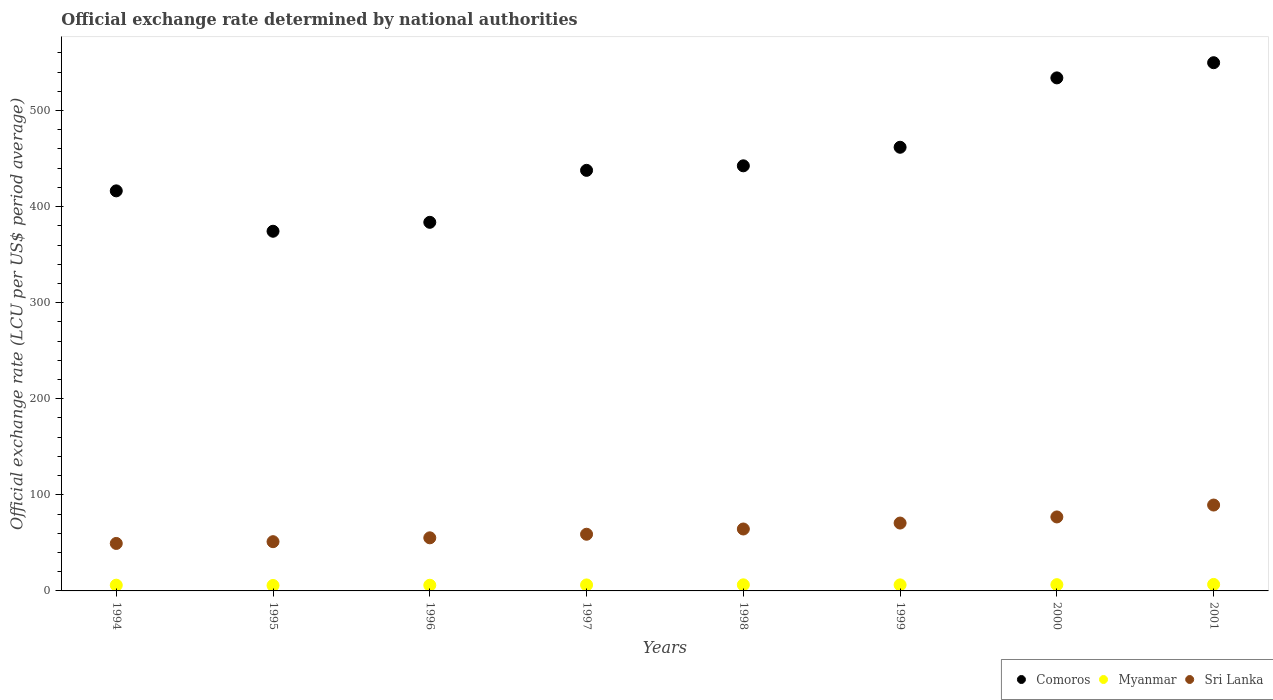How many different coloured dotlines are there?
Your answer should be compact. 3. What is the official exchange rate in Comoros in 1995?
Provide a short and direct response. 374.36. Across all years, what is the maximum official exchange rate in Comoros?
Your answer should be compact. 549.78. Across all years, what is the minimum official exchange rate in Myanmar?
Make the answer very short. 5.67. In which year was the official exchange rate in Myanmar maximum?
Your response must be concise. 2001. What is the total official exchange rate in Comoros in the graph?
Ensure brevity in your answer.  3600.16. What is the difference between the official exchange rate in Myanmar in 1995 and that in 2001?
Provide a succinct answer. -1.08. What is the difference between the official exchange rate in Comoros in 1998 and the official exchange rate in Sri Lanka in 1994?
Provide a succinct answer. 393.04. What is the average official exchange rate in Sri Lanka per year?
Provide a short and direct response. 64.55. In the year 2001, what is the difference between the official exchange rate in Comoros and official exchange rate in Myanmar?
Offer a very short reply. 543.03. What is the ratio of the official exchange rate in Sri Lanka in 1995 to that in 1996?
Offer a terse response. 0.93. Is the official exchange rate in Comoros in 1997 less than that in 2000?
Offer a terse response. Yes. Is the difference between the official exchange rate in Comoros in 1998 and 1999 greater than the difference between the official exchange rate in Myanmar in 1998 and 1999?
Ensure brevity in your answer.  No. What is the difference between the highest and the second highest official exchange rate in Myanmar?
Give a very brief answer. 0.23. What is the difference between the highest and the lowest official exchange rate in Myanmar?
Keep it short and to the point. 1.08. Is the sum of the official exchange rate in Sri Lanka in 1996 and 2001 greater than the maximum official exchange rate in Comoros across all years?
Offer a very short reply. No. Is it the case that in every year, the sum of the official exchange rate in Myanmar and official exchange rate in Sri Lanka  is greater than the official exchange rate in Comoros?
Make the answer very short. No. Does the official exchange rate in Myanmar monotonically increase over the years?
Your answer should be compact. No. Is the official exchange rate in Myanmar strictly less than the official exchange rate in Comoros over the years?
Offer a terse response. Yes. How many years are there in the graph?
Provide a succinct answer. 8. What is the difference between two consecutive major ticks on the Y-axis?
Make the answer very short. 100. Where does the legend appear in the graph?
Offer a very short reply. Bottom right. How many legend labels are there?
Keep it short and to the point. 3. What is the title of the graph?
Offer a terse response. Official exchange rate determined by national authorities. What is the label or title of the X-axis?
Your response must be concise. Years. What is the label or title of the Y-axis?
Provide a short and direct response. Official exchange rate (LCU per US$ period average). What is the Official exchange rate (LCU per US$ period average) in Comoros in 1994?
Provide a succinct answer. 416.4. What is the Official exchange rate (LCU per US$ period average) of Myanmar in 1994?
Your response must be concise. 5.97. What is the Official exchange rate (LCU per US$ period average) of Sri Lanka in 1994?
Your answer should be very brief. 49.42. What is the Official exchange rate (LCU per US$ period average) of Comoros in 1995?
Offer a very short reply. 374.36. What is the Official exchange rate (LCU per US$ period average) of Myanmar in 1995?
Provide a succinct answer. 5.67. What is the Official exchange rate (LCU per US$ period average) in Sri Lanka in 1995?
Provide a short and direct response. 51.25. What is the Official exchange rate (LCU per US$ period average) of Comoros in 1996?
Make the answer very short. 383.66. What is the Official exchange rate (LCU per US$ period average) in Myanmar in 1996?
Ensure brevity in your answer.  5.92. What is the Official exchange rate (LCU per US$ period average) of Sri Lanka in 1996?
Keep it short and to the point. 55.27. What is the Official exchange rate (LCU per US$ period average) in Comoros in 1997?
Ensure brevity in your answer.  437.75. What is the Official exchange rate (LCU per US$ period average) in Myanmar in 1997?
Make the answer very short. 6.24. What is the Official exchange rate (LCU per US$ period average) in Sri Lanka in 1997?
Keep it short and to the point. 58.99. What is the Official exchange rate (LCU per US$ period average) of Comoros in 1998?
Offer a very short reply. 442.46. What is the Official exchange rate (LCU per US$ period average) in Myanmar in 1998?
Ensure brevity in your answer.  6.34. What is the Official exchange rate (LCU per US$ period average) in Sri Lanka in 1998?
Your answer should be very brief. 64.45. What is the Official exchange rate (LCU per US$ period average) in Comoros in 1999?
Offer a very short reply. 461.77. What is the Official exchange rate (LCU per US$ period average) of Myanmar in 1999?
Offer a terse response. 6.29. What is the Official exchange rate (LCU per US$ period average) of Sri Lanka in 1999?
Your answer should be compact. 70.64. What is the Official exchange rate (LCU per US$ period average) of Comoros in 2000?
Make the answer very short. 533.98. What is the Official exchange rate (LCU per US$ period average) in Myanmar in 2000?
Your answer should be compact. 6.52. What is the Official exchange rate (LCU per US$ period average) of Sri Lanka in 2000?
Provide a short and direct response. 77.01. What is the Official exchange rate (LCU per US$ period average) in Comoros in 2001?
Give a very brief answer. 549.78. What is the Official exchange rate (LCU per US$ period average) in Myanmar in 2001?
Provide a short and direct response. 6.75. What is the Official exchange rate (LCU per US$ period average) of Sri Lanka in 2001?
Offer a terse response. 89.38. Across all years, what is the maximum Official exchange rate (LCU per US$ period average) of Comoros?
Ensure brevity in your answer.  549.78. Across all years, what is the maximum Official exchange rate (LCU per US$ period average) in Myanmar?
Give a very brief answer. 6.75. Across all years, what is the maximum Official exchange rate (LCU per US$ period average) in Sri Lanka?
Ensure brevity in your answer.  89.38. Across all years, what is the minimum Official exchange rate (LCU per US$ period average) of Comoros?
Give a very brief answer. 374.36. Across all years, what is the minimum Official exchange rate (LCU per US$ period average) in Myanmar?
Your answer should be very brief. 5.67. Across all years, what is the minimum Official exchange rate (LCU per US$ period average) in Sri Lanka?
Offer a terse response. 49.42. What is the total Official exchange rate (LCU per US$ period average) in Comoros in the graph?
Keep it short and to the point. 3600.16. What is the total Official exchange rate (LCU per US$ period average) in Myanmar in the graph?
Offer a very short reply. 49.7. What is the total Official exchange rate (LCU per US$ period average) of Sri Lanka in the graph?
Provide a succinct answer. 516.41. What is the difference between the Official exchange rate (LCU per US$ period average) of Comoros in 1994 and that in 1995?
Ensure brevity in your answer.  42.04. What is the difference between the Official exchange rate (LCU per US$ period average) in Myanmar in 1994 and that in 1995?
Ensure brevity in your answer.  0.31. What is the difference between the Official exchange rate (LCU per US$ period average) of Sri Lanka in 1994 and that in 1995?
Provide a short and direct response. -1.84. What is the difference between the Official exchange rate (LCU per US$ period average) in Comoros in 1994 and that in 1996?
Offer a terse response. 32.74. What is the difference between the Official exchange rate (LCU per US$ period average) of Myanmar in 1994 and that in 1996?
Provide a succinct answer. 0.06. What is the difference between the Official exchange rate (LCU per US$ period average) in Sri Lanka in 1994 and that in 1996?
Provide a short and direct response. -5.86. What is the difference between the Official exchange rate (LCU per US$ period average) in Comoros in 1994 and that in 1997?
Keep it short and to the point. -21.35. What is the difference between the Official exchange rate (LCU per US$ period average) of Myanmar in 1994 and that in 1997?
Provide a succinct answer. -0.27. What is the difference between the Official exchange rate (LCU per US$ period average) of Sri Lanka in 1994 and that in 1997?
Make the answer very short. -9.58. What is the difference between the Official exchange rate (LCU per US$ period average) of Comoros in 1994 and that in 1998?
Your answer should be compact. -26.06. What is the difference between the Official exchange rate (LCU per US$ period average) in Myanmar in 1994 and that in 1998?
Make the answer very short. -0.37. What is the difference between the Official exchange rate (LCU per US$ period average) of Sri Lanka in 1994 and that in 1998?
Provide a succinct answer. -15.04. What is the difference between the Official exchange rate (LCU per US$ period average) in Comoros in 1994 and that in 1999?
Your response must be concise. -45.38. What is the difference between the Official exchange rate (LCU per US$ period average) of Myanmar in 1994 and that in 1999?
Your response must be concise. -0.31. What is the difference between the Official exchange rate (LCU per US$ period average) of Sri Lanka in 1994 and that in 1999?
Keep it short and to the point. -21.22. What is the difference between the Official exchange rate (LCU per US$ period average) in Comoros in 1994 and that in 2000?
Give a very brief answer. -117.58. What is the difference between the Official exchange rate (LCU per US$ period average) in Myanmar in 1994 and that in 2000?
Provide a short and direct response. -0.54. What is the difference between the Official exchange rate (LCU per US$ period average) in Sri Lanka in 1994 and that in 2000?
Keep it short and to the point. -27.59. What is the difference between the Official exchange rate (LCU per US$ period average) in Comoros in 1994 and that in 2001?
Ensure brevity in your answer.  -133.38. What is the difference between the Official exchange rate (LCU per US$ period average) in Myanmar in 1994 and that in 2001?
Provide a succinct answer. -0.77. What is the difference between the Official exchange rate (LCU per US$ period average) of Sri Lanka in 1994 and that in 2001?
Make the answer very short. -39.97. What is the difference between the Official exchange rate (LCU per US$ period average) of Comoros in 1995 and that in 1996?
Offer a terse response. -9.3. What is the difference between the Official exchange rate (LCU per US$ period average) in Myanmar in 1995 and that in 1996?
Your response must be concise. -0.25. What is the difference between the Official exchange rate (LCU per US$ period average) of Sri Lanka in 1995 and that in 1996?
Your answer should be very brief. -4.02. What is the difference between the Official exchange rate (LCU per US$ period average) in Comoros in 1995 and that in 1997?
Your response must be concise. -63.39. What is the difference between the Official exchange rate (LCU per US$ period average) of Myanmar in 1995 and that in 1997?
Offer a terse response. -0.57. What is the difference between the Official exchange rate (LCU per US$ period average) in Sri Lanka in 1995 and that in 1997?
Provide a succinct answer. -7.74. What is the difference between the Official exchange rate (LCU per US$ period average) of Comoros in 1995 and that in 1998?
Give a very brief answer. -68.1. What is the difference between the Official exchange rate (LCU per US$ period average) in Myanmar in 1995 and that in 1998?
Your response must be concise. -0.68. What is the difference between the Official exchange rate (LCU per US$ period average) in Sri Lanka in 1995 and that in 1998?
Provide a short and direct response. -13.2. What is the difference between the Official exchange rate (LCU per US$ period average) in Comoros in 1995 and that in 1999?
Give a very brief answer. -87.42. What is the difference between the Official exchange rate (LCU per US$ period average) in Myanmar in 1995 and that in 1999?
Make the answer very short. -0.62. What is the difference between the Official exchange rate (LCU per US$ period average) of Sri Lanka in 1995 and that in 1999?
Make the answer very short. -19.38. What is the difference between the Official exchange rate (LCU per US$ period average) in Comoros in 1995 and that in 2000?
Your answer should be very brief. -159.63. What is the difference between the Official exchange rate (LCU per US$ period average) of Myanmar in 1995 and that in 2000?
Keep it short and to the point. -0.85. What is the difference between the Official exchange rate (LCU per US$ period average) in Sri Lanka in 1995 and that in 2000?
Give a very brief answer. -25.75. What is the difference between the Official exchange rate (LCU per US$ period average) in Comoros in 1995 and that in 2001?
Keep it short and to the point. -175.42. What is the difference between the Official exchange rate (LCU per US$ period average) in Myanmar in 1995 and that in 2001?
Keep it short and to the point. -1.08. What is the difference between the Official exchange rate (LCU per US$ period average) in Sri Lanka in 1995 and that in 2001?
Offer a terse response. -38.13. What is the difference between the Official exchange rate (LCU per US$ period average) in Comoros in 1996 and that in 1997?
Keep it short and to the point. -54.09. What is the difference between the Official exchange rate (LCU per US$ period average) of Myanmar in 1996 and that in 1997?
Your answer should be very brief. -0.32. What is the difference between the Official exchange rate (LCU per US$ period average) in Sri Lanka in 1996 and that in 1997?
Provide a succinct answer. -3.72. What is the difference between the Official exchange rate (LCU per US$ period average) in Comoros in 1996 and that in 1998?
Offer a terse response. -58.8. What is the difference between the Official exchange rate (LCU per US$ period average) of Myanmar in 1996 and that in 1998?
Provide a short and direct response. -0.43. What is the difference between the Official exchange rate (LCU per US$ period average) in Sri Lanka in 1996 and that in 1998?
Make the answer very short. -9.18. What is the difference between the Official exchange rate (LCU per US$ period average) in Comoros in 1996 and that in 1999?
Provide a short and direct response. -78.11. What is the difference between the Official exchange rate (LCU per US$ period average) in Myanmar in 1996 and that in 1999?
Make the answer very short. -0.37. What is the difference between the Official exchange rate (LCU per US$ period average) of Sri Lanka in 1996 and that in 1999?
Provide a succinct answer. -15.36. What is the difference between the Official exchange rate (LCU per US$ period average) of Comoros in 1996 and that in 2000?
Give a very brief answer. -150.32. What is the difference between the Official exchange rate (LCU per US$ period average) in Myanmar in 1996 and that in 2000?
Your answer should be very brief. -0.6. What is the difference between the Official exchange rate (LCU per US$ period average) in Sri Lanka in 1996 and that in 2000?
Your response must be concise. -21.73. What is the difference between the Official exchange rate (LCU per US$ period average) in Comoros in 1996 and that in 2001?
Provide a short and direct response. -166.12. What is the difference between the Official exchange rate (LCU per US$ period average) in Myanmar in 1996 and that in 2001?
Your answer should be compact. -0.83. What is the difference between the Official exchange rate (LCU per US$ period average) in Sri Lanka in 1996 and that in 2001?
Make the answer very short. -34.11. What is the difference between the Official exchange rate (LCU per US$ period average) of Comoros in 1997 and that in 1998?
Provide a succinct answer. -4.71. What is the difference between the Official exchange rate (LCU per US$ period average) of Myanmar in 1997 and that in 1998?
Provide a short and direct response. -0.1. What is the difference between the Official exchange rate (LCU per US$ period average) in Sri Lanka in 1997 and that in 1998?
Your answer should be compact. -5.46. What is the difference between the Official exchange rate (LCU per US$ period average) in Comoros in 1997 and that in 1999?
Offer a very short reply. -24.03. What is the difference between the Official exchange rate (LCU per US$ period average) of Myanmar in 1997 and that in 1999?
Offer a very short reply. -0.04. What is the difference between the Official exchange rate (LCU per US$ period average) of Sri Lanka in 1997 and that in 1999?
Offer a very short reply. -11.64. What is the difference between the Official exchange rate (LCU per US$ period average) of Comoros in 1997 and that in 2000?
Ensure brevity in your answer.  -96.24. What is the difference between the Official exchange rate (LCU per US$ period average) of Myanmar in 1997 and that in 2000?
Give a very brief answer. -0.27. What is the difference between the Official exchange rate (LCU per US$ period average) in Sri Lanka in 1997 and that in 2000?
Your response must be concise. -18.01. What is the difference between the Official exchange rate (LCU per US$ period average) of Comoros in 1997 and that in 2001?
Your answer should be compact. -112.03. What is the difference between the Official exchange rate (LCU per US$ period average) in Myanmar in 1997 and that in 2001?
Give a very brief answer. -0.51. What is the difference between the Official exchange rate (LCU per US$ period average) of Sri Lanka in 1997 and that in 2001?
Keep it short and to the point. -30.39. What is the difference between the Official exchange rate (LCU per US$ period average) of Comoros in 1998 and that in 1999?
Offer a terse response. -19.32. What is the difference between the Official exchange rate (LCU per US$ period average) of Myanmar in 1998 and that in 1999?
Provide a succinct answer. 0.06. What is the difference between the Official exchange rate (LCU per US$ period average) of Sri Lanka in 1998 and that in 1999?
Your answer should be compact. -6.19. What is the difference between the Official exchange rate (LCU per US$ period average) in Comoros in 1998 and that in 2000?
Your response must be concise. -91.52. What is the difference between the Official exchange rate (LCU per US$ period average) in Myanmar in 1998 and that in 2000?
Your answer should be very brief. -0.17. What is the difference between the Official exchange rate (LCU per US$ period average) in Sri Lanka in 1998 and that in 2000?
Offer a terse response. -12.55. What is the difference between the Official exchange rate (LCU per US$ period average) in Comoros in 1998 and that in 2001?
Your answer should be compact. -107.32. What is the difference between the Official exchange rate (LCU per US$ period average) of Myanmar in 1998 and that in 2001?
Your response must be concise. -0.41. What is the difference between the Official exchange rate (LCU per US$ period average) in Sri Lanka in 1998 and that in 2001?
Make the answer very short. -24.93. What is the difference between the Official exchange rate (LCU per US$ period average) in Comoros in 1999 and that in 2000?
Provide a short and direct response. -72.21. What is the difference between the Official exchange rate (LCU per US$ period average) in Myanmar in 1999 and that in 2000?
Offer a very short reply. -0.23. What is the difference between the Official exchange rate (LCU per US$ period average) of Sri Lanka in 1999 and that in 2000?
Your answer should be very brief. -6.37. What is the difference between the Official exchange rate (LCU per US$ period average) of Comoros in 1999 and that in 2001?
Provide a succinct answer. -88. What is the difference between the Official exchange rate (LCU per US$ period average) in Myanmar in 1999 and that in 2001?
Your answer should be very brief. -0.46. What is the difference between the Official exchange rate (LCU per US$ period average) of Sri Lanka in 1999 and that in 2001?
Give a very brief answer. -18.75. What is the difference between the Official exchange rate (LCU per US$ period average) of Comoros in 2000 and that in 2001?
Give a very brief answer. -15.8. What is the difference between the Official exchange rate (LCU per US$ period average) in Myanmar in 2000 and that in 2001?
Provide a short and direct response. -0.23. What is the difference between the Official exchange rate (LCU per US$ period average) of Sri Lanka in 2000 and that in 2001?
Provide a short and direct response. -12.38. What is the difference between the Official exchange rate (LCU per US$ period average) in Comoros in 1994 and the Official exchange rate (LCU per US$ period average) in Myanmar in 1995?
Keep it short and to the point. 410.73. What is the difference between the Official exchange rate (LCU per US$ period average) in Comoros in 1994 and the Official exchange rate (LCU per US$ period average) in Sri Lanka in 1995?
Provide a succinct answer. 365.15. What is the difference between the Official exchange rate (LCU per US$ period average) of Myanmar in 1994 and the Official exchange rate (LCU per US$ period average) of Sri Lanka in 1995?
Keep it short and to the point. -45.28. What is the difference between the Official exchange rate (LCU per US$ period average) in Comoros in 1994 and the Official exchange rate (LCU per US$ period average) in Myanmar in 1996?
Ensure brevity in your answer.  410.48. What is the difference between the Official exchange rate (LCU per US$ period average) in Comoros in 1994 and the Official exchange rate (LCU per US$ period average) in Sri Lanka in 1996?
Your answer should be compact. 361.13. What is the difference between the Official exchange rate (LCU per US$ period average) in Myanmar in 1994 and the Official exchange rate (LCU per US$ period average) in Sri Lanka in 1996?
Your answer should be very brief. -49.3. What is the difference between the Official exchange rate (LCU per US$ period average) of Comoros in 1994 and the Official exchange rate (LCU per US$ period average) of Myanmar in 1997?
Your response must be concise. 410.16. What is the difference between the Official exchange rate (LCU per US$ period average) of Comoros in 1994 and the Official exchange rate (LCU per US$ period average) of Sri Lanka in 1997?
Make the answer very short. 357.4. What is the difference between the Official exchange rate (LCU per US$ period average) of Myanmar in 1994 and the Official exchange rate (LCU per US$ period average) of Sri Lanka in 1997?
Keep it short and to the point. -53.02. What is the difference between the Official exchange rate (LCU per US$ period average) in Comoros in 1994 and the Official exchange rate (LCU per US$ period average) in Myanmar in 1998?
Your response must be concise. 410.06. What is the difference between the Official exchange rate (LCU per US$ period average) of Comoros in 1994 and the Official exchange rate (LCU per US$ period average) of Sri Lanka in 1998?
Give a very brief answer. 351.95. What is the difference between the Official exchange rate (LCU per US$ period average) in Myanmar in 1994 and the Official exchange rate (LCU per US$ period average) in Sri Lanka in 1998?
Your answer should be compact. -58.48. What is the difference between the Official exchange rate (LCU per US$ period average) in Comoros in 1994 and the Official exchange rate (LCU per US$ period average) in Myanmar in 1999?
Your answer should be compact. 410.11. What is the difference between the Official exchange rate (LCU per US$ period average) in Comoros in 1994 and the Official exchange rate (LCU per US$ period average) in Sri Lanka in 1999?
Provide a succinct answer. 345.76. What is the difference between the Official exchange rate (LCU per US$ period average) of Myanmar in 1994 and the Official exchange rate (LCU per US$ period average) of Sri Lanka in 1999?
Your answer should be very brief. -64.66. What is the difference between the Official exchange rate (LCU per US$ period average) of Comoros in 1994 and the Official exchange rate (LCU per US$ period average) of Myanmar in 2000?
Give a very brief answer. 409.88. What is the difference between the Official exchange rate (LCU per US$ period average) in Comoros in 1994 and the Official exchange rate (LCU per US$ period average) in Sri Lanka in 2000?
Offer a terse response. 339.39. What is the difference between the Official exchange rate (LCU per US$ period average) in Myanmar in 1994 and the Official exchange rate (LCU per US$ period average) in Sri Lanka in 2000?
Offer a terse response. -71.03. What is the difference between the Official exchange rate (LCU per US$ period average) of Comoros in 1994 and the Official exchange rate (LCU per US$ period average) of Myanmar in 2001?
Offer a very short reply. 409.65. What is the difference between the Official exchange rate (LCU per US$ period average) of Comoros in 1994 and the Official exchange rate (LCU per US$ period average) of Sri Lanka in 2001?
Keep it short and to the point. 327.02. What is the difference between the Official exchange rate (LCU per US$ period average) in Myanmar in 1994 and the Official exchange rate (LCU per US$ period average) in Sri Lanka in 2001?
Your answer should be compact. -83.41. What is the difference between the Official exchange rate (LCU per US$ period average) in Comoros in 1995 and the Official exchange rate (LCU per US$ period average) in Myanmar in 1996?
Provide a short and direct response. 368.44. What is the difference between the Official exchange rate (LCU per US$ period average) of Comoros in 1995 and the Official exchange rate (LCU per US$ period average) of Sri Lanka in 1996?
Your response must be concise. 319.09. What is the difference between the Official exchange rate (LCU per US$ period average) in Myanmar in 1995 and the Official exchange rate (LCU per US$ period average) in Sri Lanka in 1996?
Keep it short and to the point. -49.6. What is the difference between the Official exchange rate (LCU per US$ period average) of Comoros in 1995 and the Official exchange rate (LCU per US$ period average) of Myanmar in 1997?
Ensure brevity in your answer.  368.12. What is the difference between the Official exchange rate (LCU per US$ period average) of Comoros in 1995 and the Official exchange rate (LCU per US$ period average) of Sri Lanka in 1997?
Your answer should be very brief. 315.36. What is the difference between the Official exchange rate (LCU per US$ period average) in Myanmar in 1995 and the Official exchange rate (LCU per US$ period average) in Sri Lanka in 1997?
Offer a terse response. -53.33. What is the difference between the Official exchange rate (LCU per US$ period average) of Comoros in 1995 and the Official exchange rate (LCU per US$ period average) of Myanmar in 1998?
Your answer should be compact. 368.01. What is the difference between the Official exchange rate (LCU per US$ period average) of Comoros in 1995 and the Official exchange rate (LCU per US$ period average) of Sri Lanka in 1998?
Give a very brief answer. 309.91. What is the difference between the Official exchange rate (LCU per US$ period average) of Myanmar in 1995 and the Official exchange rate (LCU per US$ period average) of Sri Lanka in 1998?
Ensure brevity in your answer.  -58.78. What is the difference between the Official exchange rate (LCU per US$ period average) in Comoros in 1995 and the Official exchange rate (LCU per US$ period average) in Myanmar in 1999?
Offer a very short reply. 368.07. What is the difference between the Official exchange rate (LCU per US$ period average) in Comoros in 1995 and the Official exchange rate (LCU per US$ period average) in Sri Lanka in 1999?
Make the answer very short. 303.72. What is the difference between the Official exchange rate (LCU per US$ period average) of Myanmar in 1995 and the Official exchange rate (LCU per US$ period average) of Sri Lanka in 1999?
Ensure brevity in your answer.  -64.97. What is the difference between the Official exchange rate (LCU per US$ period average) in Comoros in 1995 and the Official exchange rate (LCU per US$ period average) in Myanmar in 2000?
Ensure brevity in your answer.  367.84. What is the difference between the Official exchange rate (LCU per US$ period average) of Comoros in 1995 and the Official exchange rate (LCU per US$ period average) of Sri Lanka in 2000?
Offer a terse response. 297.35. What is the difference between the Official exchange rate (LCU per US$ period average) in Myanmar in 1995 and the Official exchange rate (LCU per US$ period average) in Sri Lanka in 2000?
Keep it short and to the point. -71.34. What is the difference between the Official exchange rate (LCU per US$ period average) in Comoros in 1995 and the Official exchange rate (LCU per US$ period average) in Myanmar in 2001?
Your answer should be compact. 367.61. What is the difference between the Official exchange rate (LCU per US$ period average) of Comoros in 1995 and the Official exchange rate (LCU per US$ period average) of Sri Lanka in 2001?
Give a very brief answer. 284.97. What is the difference between the Official exchange rate (LCU per US$ period average) of Myanmar in 1995 and the Official exchange rate (LCU per US$ period average) of Sri Lanka in 2001?
Give a very brief answer. -83.72. What is the difference between the Official exchange rate (LCU per US$ period average) in Comoros in 1996 and the Official exchange rate (LCU per US$ period average) in Myanmar in 1997?
Provide a succinct answer. 377.42. What is the difference between the Official exchange rate (LCU per US$ period average) of Comoros in 1996 and the Official exchange rate (LCU per US$ period average) of Sri Lanka in 1997?
Ensure brevity in your answer.  324.67. What is the difference between the Official exchange rate (LCU per US$ period average) in Myanmar in 1996 and the Official exchange rate (LCU per US$ period average) in Sri Lanka in 1997?
Make the answer very short. -53.08. What is the difference between the Official exchange rate (LCU per US$ period average) of Comoros in 1996 and the Official exchange rate (LCU per US$ period average) of Myanmar in 1998?
Keep it short and to the point. 377.32. What is the difference between the Official exchange rate (LCU per US$ period average) of Comoros in 1996 and the Official exchange rate (LCU per US$ period average) of Sri Lanka in 1998?
Your response must be concise. 319.21. What is the difference between the Official exchange rate (LCU per US$ period average) in Myanmar in 1996 and the Official exchange rate (LCU per US$ period average) in Sri Lanka in 1998?
Keep it short and to the point. -58.53. What is the difference between the Official exchange rate (LCU per US$ period average) in Comoros in 1996 and the Official exchange rate (LCU per US$ period average) in Myanmar in 1999?
Your response must be concise. 377.37. What is the difference between the Official exchange rate (LCU per US$ period average) in Comoros in 1996 and the Official exchange rate (LCU per US$ period average) in Sri Lanka in 1999?
Your answer should be very brief. 313.02. What is the difference between the Official exchange rate (LCU per US$ period average) in Myanmar in 1996 and the Official exchange rate (LCU per US$ period average) in Sri Lanka in 1999?
Give a very brief answer. -64.72. What is the difference between the Official exchange rate (LCU per US$ period average) in Comoros in 1996 and the Official exchange rate (LCU per US$ period average) in Myanmar in 2000?
Provide a short and direct response. 377.14. What is the difference between the Official exchange rate (LCU per US$ period average) of Comoros in 1996 and the Official exchange rate (LCU per US$ period average) of Sri Lanka in 2000?
Give a very brief answer. 306.65. What is the difference between the Official exchange rate (LCU per US$ period average) in Myanmar in 1996 and the Official exchange rate (LCU per US$ period average) in Sri Lanka in 2000?
Your answer should be very brief. -71.09. What is the difference between the Official exchange rate (LCU per US$ period average) of Comoros in 1996 and the Official exchange rate (LCU per US$ period average) of Myanmar in 2001?
Your response must be concise. 376.91. What is the difference between the Official exchange rate (LCU per US$ period average) in Comoros in 1996 and the Official exchange rate (LCU per US$ period average) in Sri Lanka in 2001?
Your answer should be very brief. 294.28. What is the difference between the Official exchange rate (LCU per US$ period average) in Myanmar in 1996 and the Official exchange rate (LCU per US$ period average) in Sri Lanka in 2001?
Keep it short and to the point. -83.47. What is the difference between the Official exchange rate (LCU per US$ period average) of Comoros in 1997 and the Official exchange rate (LCU per US$ period average) of Myanmar in 1998?
Your answer should be very brief. 431.4. What is the difference between the Official exchange rate (LCU per US$ period average) of Comoros in 1997 and the Official exchange rate (LCU per US$ period average) of Sri Lanka in 1998?
Offer a very short reply. 373.3. What is the difference between the Official exchange rate (LCU per US$ period average) in Myanmar in 1997 and the Official exchange rate (LCU per US$ period average) in Sri Lanka in 1998?
Offer a terse response. -58.21. What is the difference between the Official exchange rate (LCU per US$ period average) of Comoros in 1997 and the Official exchange rate (LCU per US$ period average) of Myanmar in 1999?
Give a very brief answer. 431.46. What is the difference between the Official exchange rate (LCU per US$ period average) in Comoros in 1997 and the Official exchange rate (LCU per US$ period average) in Sri Lanka in 1999?
Keep it short and to the point. 367.11. What is the difference between the Official exchange rate (LCU per US$ period average) of Myanmar in 1997 and the Official exchange rate (LCU per US$ period average) of Sri Lanka in 1999?
Ensure brevity in your answer.  -64.39. What is the difference between the Official exchange rate (LCU per US$ period average) in Comoros in 1997 and the Official exchange rate (LCU per US$ period average) in Myanmar in 2000?
Ensure brevity in your answer.  431.23. What is the difference between the Official exchange rate (LCU per US$ period average) of Comoros in 1997 and the Official exchange rate (LCU per US$ period average) of Sri Lanka in 2000?
Provide a short and direct response. 360.74. What is the difference between the Official exchange rate (LCU per US$ period average) of Myanmar in 1997 and the Official exchange rate (LCU per US$ period average) of Sri Lanka in 2000?
Provide a succinct answer. -70.76. What is the difference between the Official exchange rate (LCU per US$ period average) in Comoros in 1997 and the Official exchange rate (LCU per US$ period average) in Myanmar in 2001?
Your answer should be compact. 431. What is the difference between the Official exchange rate (LCU per US$ period average) in Comoros in 1997 and the Official exchange rate (LCU per US$ period average) in Sri Lanka in 2001?
Offer a terse response. 348.36. What is the difference between the Official exchange rate (LCU per US$ period average) in Myanmar in 1997 and the Official exchange rate (LCU per US$ period average) in Sri Lanka in 2001?
Provide a short and direct response. -83.14. What is the difference between the Official exchange rate (LCU per US$ period average) in Comoros in 1998 and the Official exchange rate (LCU per US$ period average) in Myanmar in 1999?
Provide a short and direct response. 436.17. What is the difference between the Official exchange rate (LCU per US$ period average) in Comoros in 1998 and the Official exchange rate (LCU per US$ period average) in Sri Lanka in 1999?
Your answer should be very brief. 371.82. What is the difference between the Official exchange rate (LCU per US$ period average) in Myanmar in 1998 and the Official exchange rate (LCU per US$ period average) in Sri Lanka in 1999?
Keep it short and to the point. -64.29. What is the difference between the Official exchange rate (LCU per US$ period average) in Comoros in 1998 and the Official exchange rate (LCU per US$ period average) in Myanmar in 2000?
Your answer should be compact. 435.94. What is the difference between the Official exchange rate (LCU per US$ period average) in Comoros in 1998 and the Official exchange rate (LCU per US$ period average) in Sri Lanka in 2000?
Offer a terse response. 365.45. What is the difference between the Official exchange rate (LCU per US$ period average) in Myanmar in 1998 and the Official exchange rate (LCU per US$ period average) in Sri Lanka in 2000?
Give a very brief answer. -70.66. What is the difference between the Official exchange rate (LCU per US$ period average) in Comoros in 1998 and the Official exchange rate (LCU per US$ period average) in Myanmar in 2001?
Ensure brevity in your answer.  435.71. What is the difference between the Official exchange rate (LCU per US$ period average) in Comoros in 1998 and the Official exchange rate (LCU per US$ period average) in Sri Lanka in 2001?
Offer a terse response. 353.08. What is the difference between the Official exchange rate (LCU per US$ period average) of Myanmar in 1998 and the Official exchange rate (LCU per US$ period average) of Sri Lanka in 2001?
Keep it short and to the point. -83.04. What is the difference between the Official exchange rate (LCU per US$ period average) of Comoros in 1999 and the Official exchange rate (LCU per US$ period average) of Myanmar in 2000?
Offer a terse response. 455.26. What is the difference between the Official exchange rate (LCU per US$ period average) of Comoros in 1999 and the Official exchange rate (LCU per US$ period average) of Sri Lanka in 2000?
Give a very brief answer. 384.77. What is the difference between the Official exchange rate (LCU per US$ period average) in Myanmar in 1999 and the Official exchange rate (LCU per US$ period average) in Sri Lanka in 2000?
Your answer should be very brief. -70.72. What is the difference between the Official exchange rate (LCU per US$ period average) in Comoros in 1999 and the Official exchange rate (LCU per US$ period average) in Myanmar in 2001?
Ensure brevity in your answer.  455.03. What is the difference between the Official exchange rate (LCU per US$ period average) in Comoros in 1999 and the Official exchange rate (LCU per US$ period average) in Sri Lanka in 2001?
Make the answer very short. 372.39. What is the difference between the Official exchange rate (LCU per US$ period average) of Myanmar in 1999 and the Official exchange rate (LCU per US$ period average) of Sri Lanka in 2001?
Provide a succinct answer. -83.1. What is the difference between the Official exchange rate (LCU per US$ period average) in Comoros in 2000 and the Official exchange rate (LCU per US$ period average) in Myanmar in 2001?
Ensure brevity in your answer.  527.23. What is the difference between the Official exchange rate (LCU per US$ period average) of Comoros in 2000 and the Official exchange rate (LCU per US$ period average) of Sri Lanka in 2001?
Your answer should be compact. 444.6. What is the difference between the Official exchange rate (LCU per US$ period average) in Myanmar in 2000 and the Official exchange rate (LCU per US$ period average) in Sri Lanka in 2001?
Your response must be concise. -82.87. What is the average Official exchange rate (LCU per US$ period average) in Comoros per year?
Make the answer very short. 450.02. What is the average Official exchange rate (LCU per US$ period average) in Myanmar per year?
Your answer should be compact. 6.21. What is the average Official exchange rate (LCU per US$ period average) of Sri Lanka per year?
Keep it short and to the point. 64.55. In the year 1994, what is the difference between the Official exchange rate (LCU per US$ period average) in Comoros and Official exchange rate (LCU per US$ period average) in Myanmar?
Your response must be concise. 410.42. In the year 1994, what is the difference between the Official exchange rate (LCU per US$ period average) of Comoros and Official exchange rate (LCU per US$ period average) of Sri Lanka?
Ensure brevity in your answer.  366.98. In the year 1994, what is the difference between the Official exchange rate (LCU per US$ period average) in Myanmar and Official exchange rate (LCU per US$ period average) in Sri Lanka?
Give a very brief answer. -43.44. In the year 1995, what is the difference between the Official exchange rate (LCU per US$ period average) in Comoros and Official exchange rate (LCU per US$ period average) in Myanmar?
Give a very brief answer. 368.69. In the year 1995, what is the difference between the Official exchange rate (LCU per US$ period average) of Comoros and Official exchange rate (LCU per US$ period average) of Sri Lanka?
Offer a terse response. 323.11. In the year 1995, what is the difference between the Official exchange rate (LCU per US$ period average) in Myanmar and Official exchange rate (LCU per US$ period average) in Sri Lanka?
Ensure brevity in your answer.  -45.58. In the year 1996, what is the difference between the Official exchange rate (LCU per US$ period average) in Comoros and Official exchange rate (LCU per US$ period average) in Myanmar?
Offer a terse response. 377.74. In the year 1996, what is the difference between the Official exchange rate (LCU per US$ period average) in Comoros and Official exchange rate (LCU per US$ period average) in Sri Lanka?
Ensure brevity in your answer.  328.39. In the year 1996, what is the difference between the Official exchange rate (LCU per US$ period average) in Myanmar and Official exchange rate (LCU per US$ period average) in Sri Lanka?
Ensure brevity in your answer.  -49.35. In the year 1997, what is the difference between the Official exchange rate (LCU per US$ period average) in Comoros and Official exchange rate (LCU per US$ period average) in Myanmar?
Your answer should be very brief. 431.51. In the year 1997, what is the difference between the Official exchange rate (LCU per US$ period average) in Comoros and Official exchange rate (LCU per US$ period average) in Sri Lanka?
Keep it short and to the point. 378.75. In the year 1997, what is the difference between the Official exchange rate (LCU per US$ period average) in Myanmar and Official exchange rate (LCU per US$ period average) in Sri Lanka?
Your response must be concise. -52.75. In the year 1998, what is the difference between the Official exchange rate (LCU per US$ period average) in Comoros and Official exchange rate (LCU per US$ period average) in Myanmar?
Give a very brief answer. 436.12. In the year 1998, what is the difference between the Official exchange rate (LCU per US$ period average) of Comoros and Official exchange rate (LCU per US$ period average) of Sri Lanka?
Provide a succinct answer. 378.01. In the year 1998, what is the difference between the Official exchange rate (LCU per US$ period average) in Myanmar and Official exchange rate (LCU per US$ period average) in Sri Lanka?
Offer a terse response. -58.11. In the year 1999, what is the difference between the Official exchange rate (LCU per US$ period average) of Comoros and Official exchange rate (LCU per US$ period average) of Myanmar?
Provide a succinct answer. 455.49. In the year 1999, what is the difference between the Official exchange rate (LCU per US$ period average) in Comoros and Official exchange rate (LCU per US$ period average) in Sri Lanka?
Your answer should be very brief. 391.14. In the year 1999, what is the difference between the Official exchange rate (LCU per US$ period average) of Myanmar and Official exchange rate (LCU per US$ period average) of Sri Lanka?
Provide a succinct answer. -64.35. In the year 2000, what is the difference between the Official exchange rate (LCU per US$ period average) in Comoros and Official exchange rate (LCU per US$ period average) in Myanmar?
Give a very brief answer. 527.47. In the year 2000, what is the difference between the Official exchange rate (LCU per US$ period average) in Comoros and Official exchange rate (LCU per US$ period average) in Sri Lanka?
Make the answer very short. 456.98. In the year 2000, what is the difference between the Official exchange rate (LCU per US$ period average) of Myanmar and Official exchange rate (LCU per US$ period average) of Sri Lanka?
Your response must be concise. -70.49. In the year 2001, what is the difference between the Official exchange rate (LCU per US$ period average) of Comoros and Official exchange rate (LCU per US$ period average) of Myanmar?
Give a very brief answer. 543.03. In the year 2001, what is the difference between the Official exchange rate (LCU per US$ period average) in Comoros and Official exchange rate (LCU per US$ period average) in Sri Lanka?
Offer a very short reply. 460.4. In the year 2001, what is the difference between the Official exchange rate (LCU per US$ period average) of Myanmar and Official exchange rate (LCU per US$ period average) of Sri Lanka?
Keep it short and to the point. -82.63. What is the ratio of the Official exchange rate (LCU per US$ period average) in Comoros in 1994 to that in 1995?
Your answer should be compact. 1.11. What is the ratio of the Official exchange rate (LCU per US$ period average) in Myanmar in 1994 to that in 1995?
Make the answer very short. 1.05. What is the ratio of the Official exchange rate (LCU per US$ period average) in Sri Lanka in 1994 to that in 1995?
Your response must be concise. 0.96. What is the ratio of the Official exchange rate (LCU per US$ period average) of Comoros in 1994 to that in 1996?
Make the answer very short. 1.09. What is the ratio of the Official exchange rate (LCU per US$ period average) in Myanmar in 1994 to that in 1996?
Offer a terse response. 1.01. What is the ratio of the Official exchange rate (LCU per US$ period average) of Sri Lanka in 1994 to that in 1996?
Provide a succinct answer. 0.89. What is the ratio of the Official exchange rate (LCU per US$ period average) of Comoros in 1994 to that in 1997?
Keep it short and to the point. 0.95. What is the ratio of the Official exchange rate (LCU per US$ period average) in Myanmar in 1994 to that in 1997?
Offer a terse response. 0.96. What is the ratio of the Official exchange rate (LCU per US$ period average) in Sri Lanka in 1994 to that in 1997?
Your answer should be compact. 0.84. What is the ratio of the Official exchange rate (LCU per US$ period average) of Comoros in 1994 to that in 1998?
Give a very brief answer. 0.94. What is the ratio of the Official exchange rate (LCU per US$ period average) of Myanmar in 1994 to that in 1998?
Provide a succinct answer. 0.94. What is the ratio of the Official exchange rate (LCU per US$ period average) in Sri Lanka in 1994 to that in 1998?
Ensure brevity in your answer.  0.77. What is the ratio of the Official exchange rate (LCU per US$ period average) in Comoros in 1994 to that in 1999?
Offer a terse response. 0.9. What is the ratio of the Official exchange rate (LCU per US$ period average) of Myanmar in 1994 to that in 1999?
Provide a succinct answer. 0.95. What is the ratio of the Official exchange rate (LCU per US$ period average) in Sri Lanka in 1994 to that in 1999?
Provide a short and direct response. 0.7. What is the ratio of the Official exchange rate (LCU per US$ period average) in Comoros in 1994 to that in 2000?
Provide a succinct answer. 0.78. What is the ratio of the Official exchange rate (LCU per US$ period average) in Myanmar in 1994 to that in 2000?
Give a very brief answer. 0.92. What is the ratio of the Official exchange rate (LCU per US$ period average) of Sri Lanka in 1994 to that in 2000?
Ensure brevity in your answer.  0.64. What is the ratio of the Official exchange rate (LCU per US$ period average) of Comoros in 1994 to that in 2001?
Make the answer very short. 0.76. What is the ratio of the Official exchange rate (LCU per US$ period average) of Myanmar in 1994 to that in 2001?
Make the answer very short. 0.89. What is the ratio of the Official exchange rate (LCU per US$ period average) of Sri Lanka in 1994 to that in 2001?
Keep it short and to the point. 0.55. What is the ratio of the Official exchange rate (LCU per US$ period average) in Comoros in 1995 to that in 1996?
Make the answer very short. 0.98. What is the ratio of the Official exchange rate (LCU per US$ period average) of Myanmar in 1995 to that in 1996?
Make the answer very short. 0.96. What is the ratio of the Official exchange rate (LCU per US$ period average) of Sri Lanka in 1995 to that in 1996?
Make the answer very short. 0.93. What is the ratio of the Official exchange rate (LCU per US$ period average) of Comoros in 1995 to that in 1997?
Your answer should be very brief. 0.86. What is the ratio of the Official exchange rate (LCU per US$ period average) in Myanmar in 1995 to that in 1997?
Provide a short and direct response. 0.91. What is the ratio of the Official exchange rate (LCU per US$ period average) in Sri Lanka in 1995 to that in 1997?
Give a very brief answer. 0.87. What is the ratio of the Official exchange rate (LCU per US$ period average) in Comoros in 1995 to that in 1998?
Offer a very short reply. 0.85. What is the ratio of the Official exchange rate (LCU per US$ period average) in Myanmar in 1995 to that in 1998?
Ensure brevity in your answer.  0.89. What is the ratio of the Official exchange rate (LCU per US$ period average) of Sri Lanka in 1995 to that in 1998?
Offer a very short reply. 0.8. What is the ratio of the Official exchange rate (LCU per US$ period average) in Comoros in 1995 to that in 1999?
Make the answer very short. 0.81. What is the ratio of the Official exchange rate (LCU per US$ period average) in Myanmar in 1995 to that in 1999?
Offer a very short reply. 0.9. What is the ratio of the Official exchange rate (LCU per US$ period average) in Sri Lanka in 1995 to that in 1999?
Offer a terse response. 0.73. What is the ratio of the Official exchange rate (LCU per US$ period average) in Comoros in 1995 to that in 2000?
Provide a succinct answer. 0.7. What is the ratio of the Official exchange rate (LCU per US$ period average) in Myanmar in 1995 to that in 2000?
Offer a very short reply. 0.87. What is the ratio of the Official exchange rate (LCU per US$ period average) in Sri Lanka in 1995 to that in 2000?
Your response must be concise. 0.67. What is the ratio of the Official exchange rate (LCU per US$ period average) of Comoros in 1995 to that in 2001?
Provide a succinct answer. 0.68. What is the ratio of the Official exchange rate (LCU per US$ period average) of Myanmar in 1995 to that in 2001?
Give a very brief answer. 0.84. What is the ratio of the Official exchange rate (LCU per US$ period average) of Sri Lanka in 1995 to that in 2001?
Make the answer very short. 0.57. What is the ratio of the Official exchange rate (LCU per US$ period average) in Comoros in 1996 to that in 1997?
Keep it short and to the point. 0.88. What is the ratio of the Official exchange rate (LCU per US$ period average) of Myanmar in 1996 to that in 1997?
Provide a succinct answer. 0.95. What is the ratio of the Official exchange rate (LCU per US$ period average) in Sri Lanka in 1996 to that in 1997?
Your answer should be very brief. 0.94. What is the ratio of the Official exchange rate (LCU per US$ period average) of Comoros in 1996 to that in 1998?
Keep it short and to the point. 0.87. What is the ratio of the Official exchange rate (LCU per US$ period average) of Myanmar in 1996 to that in 1998?
Make the answer very short. 0.93. What is the ratio of the Official exchange rate (LCU per US$ period average) in Sri Lanka in 1996 to that in 1998?
Provide a succinct answer. 0.86. What is the ratio of the Official exchange rate (LCU per US$ period average) in Comoros in 1996 to that in 1999?
Offer a very short reply. 0.83. What is the ratio of the Official exchange rate (LCU per US$ period average) of Myanmar in 1996 to that in 1999?
Provide a short and direct response. 0.94. What is the ratio of the Official exchange rate (LCU per US$ period average) of Sri Lanka in 1996 to that in 1999?
Offer a very short reply. 0.78. What is the ratio of the Official exchange rate (LCU per US$ period average) of Comoros in 1996 to that in 2000?
Your response must be concise. 0.72. What is the ratio of the Official exchange rate (LCU per US$ period average) in Myanmar in 1996 to that in 2000?
Make the answer very short. 0.91. What is the ratio of the Official exchange rate (LCU per US$ period average) of Sri Lanka in 1996 to that in 2000?
Your answer should be compact. 0.72. What is the ratio of the Official exchange rate (LCU per US$ period average) of Comoros in 1996 to that in 2001?
Ensure brevity in your answer.  0.7. What is the ratio of the Official exchange rate (LCU per US$ period average) of Myanmar in 1996 to that in 2001?
Make the answer very short. 0.88. What is the ratio of the Official exchange rate (LCU per US$ period average) in Sri Lanka in 1996 to that in 2001?
Give a very brief answer. 0.62. What is the ratio of the Official exchange rate (LCU per US$ period average) of Comoros in 1997 to that in 1998?
Give a very brief answer. 0.99. What is the ratio of the Official exchange rate (LCU per US$ period average) of Myanmar in 1997 to that in 1998?
Give a very brief answer. 0.98. What is the ratio of the Official exchange rate (LCU per US$ period average) in Sri Lanka in 1997 to that in 1998?
Your answer should be very brief. 0.92. What is the ratio of the Official exchange rate (LCU per US$ period average) in Comoros in 1997 to that in 1999?
Keep it short and to the point. 0.95. What is the ratio of the Official exchange rate (LCU per US$ period average) in Sri Lanka in 1997 to that in 1999?
Keep it short and to the point. 0.84. What is the ratio of the Official exchange rate (LCU per US$ period average) of Comoros in 1997 to that in 2000?
Your response must be concise. 0.82. What is the ratio of the Official exchange rate (LCU per US$ period average) of Myanmar in 1997 to that in 2000?
Give a very brief answer. 0.96. What is the ratio of the Official exchange rate (LCU per US$ period average) in Sri Lanka in 1997 to that in 2000?
Provide a short and direct response. 0.77. What is the ratio of the Official exchange rate (LCU per US$ period average) of Comoros in 1997 to that in 2001?
Offer a terse response. 0.8. What is the ratio of the Official exchange rate (LCU per US$ period average) in Myanmar in 1997 to that in 2001?
Offer a terse response. 0.92. What is the ratio of the Official exchange rate (LCU per US$ period average) in Sri Lanka in 1997 to that in 2001?
Offer a terse response. 0.66. What is the ratio of the Official exchange rate (LCU per US$ period average) in Comoros in 1998 to that in 1999?
Your response must be concise. 0.96. What is the ratio of the Official exchange rate (LCU per US$ period average) in Myanmar in 1998 to that in 1999?
Offer a very short reply. 1.01. What is the ratio of the Official exchange rate (LCU per US$ period average) in Sri Lanka in 1998 to that in 1999?
Offer a terse response. 0.91. What is the ratio of the Official exchange rate (LCU per US$ period average) of Comoros in 1998 to that in 2000?
Your answer should be very brief. 0.83. What is the ratio of the Official exchange rate (LCU per US$ period average) in Myanmar in 1998 to that in 2000?
Provide a short and direct response. 0.97. What is the ratio of the Official exchange rate (LCU per US$ period average) of Sri Lanka in 1998 to that in 2000?
Keep it short and to the point. 0.84. What is the ratio of the Official exchange rate (LCU per US$ period average) of Comoros in 1998 to that in 2001?
Provide a succinct answer. 0.8. What is the ratio of the Official exchange rate (LCU per US$ period average) of Myanmar in 1998 to that in 2001?
Provide a short and direct response. 0.94. What is the ratio of the Official exchange rate (LCU per US$ period average) of Sri Lanka in 1998 to that in 2001?
Give a very brief answer. 0.72. What is the ratio of the Official exchange rate (LCU per US$ period average) of Comoros in 1999 to that in 2000?
Provide a short and direct response. 0.86. What is the ratio of the Official exchange rate (LCU per US$ period average) of Myanmar in 1999 to that in 2000?
Offer a very short reply. 0.96. What is the ratio of the Official exchange rate (LCU per US$ period average) in Sri Lanka in 1999 to that in 2000?
Provide a short and direct response. 0.92. What is the ratio of the Official exchange rate (LCU per US$ period average) of Comoros in 1999 to that in 2001?
Offer a terse response. 0.84. What is the ratio of the Official exchange rate (LCU per US$ period average) of Myanmar in 1999 to that in 2001?
Provide a short and direct response. 0.93. What is the ratio of the Official exchange rate (LCU per US$ period average) of Sri Lanka in 1999 to that in 2001?
Offer a terse response. 0.79. What is the ratio of the Official exchange rate (LCU per US$ period average) of Comoros in 2000 to that in 2001?
Offer a terse response. 0.97. What is the ratio of the Official exchange rate (LCU per US$ period average) of Myanmar in 2000 to that in 2001?
Your answer should be compact. 0.97. What is the ratio of the Official exchange rate (LCU per US$ period average) of Sri Lanka in 2000 to that in 2001?
Your answer should be compact. 0.86. What is the difference between the highest and the second highest Official exchange rate (LCU per US$ period average) of Comoros?
Make the answer very short. 15.8. What is the difference between the highest and the second highest Official exchange rate (LCU per US$ period average) of Myanmar?
Provide a succinct answer. 0.23. What is the difference between the highest and the second highest Official exchange rate (LCU per US$ period average) of Sri Lanka?
Offer a terse response. 12.38. What is the difference between the highest and the lowest Official exchange rate (LCU per US$ period average) in Comoros?
Provide a succinct answer. 175.42. What is the difference between the highest and the lowest Official exchange rate (LCU per US$ period average) in Myanmar?
Provide a short and direct response. 1.08. What is the difference between the highest and the lowest Official exchange rate (LCU per US$ period average) of Sri Lanka?
Make the answer very short. 39.97. 